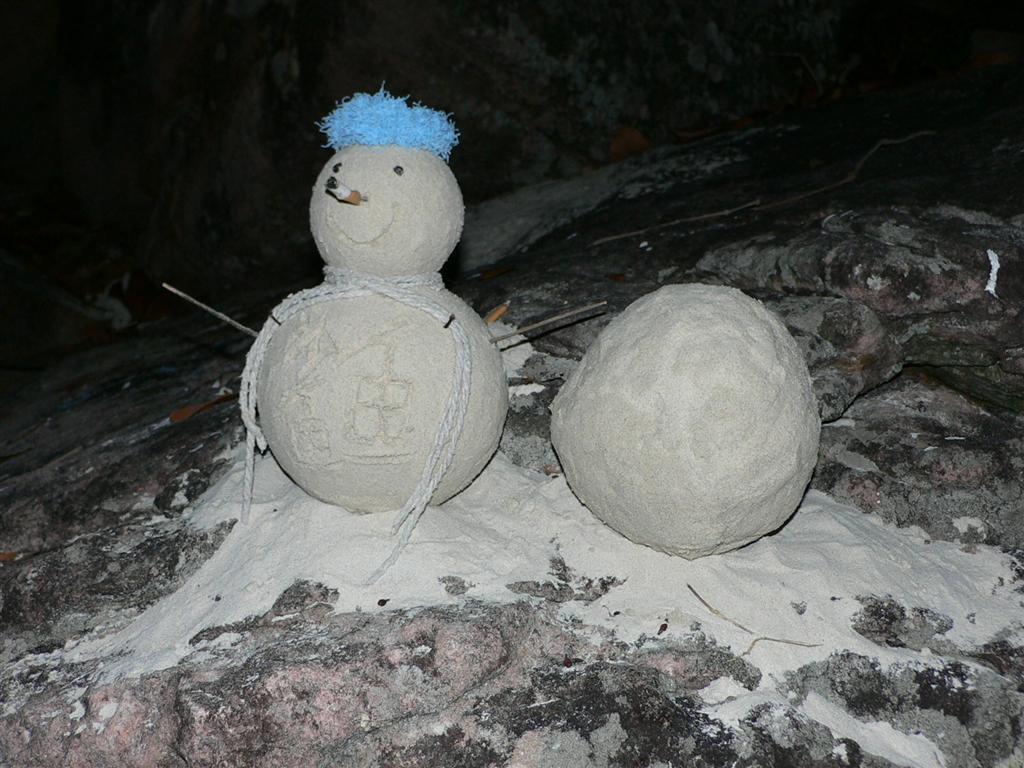How would you summarize this image in a sentence or two? In this picture I can see a doll and another concrete ball on the rock and I can see few instruments and another rock in the back. 